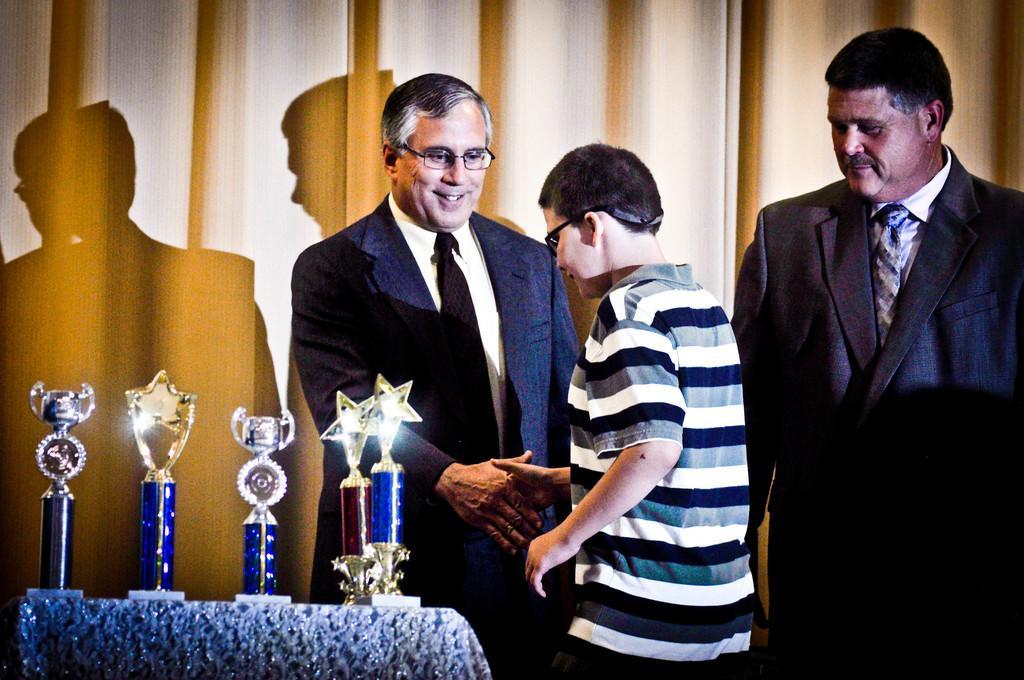How would you summarize this image in a sentence or two? In this image, we can see three persons are standing. Here two persons are shaking their hands with each other. Here a man in a suit is smiling. On the left side bottom, we can see trophies on the cloth. Background we can see curtain. 